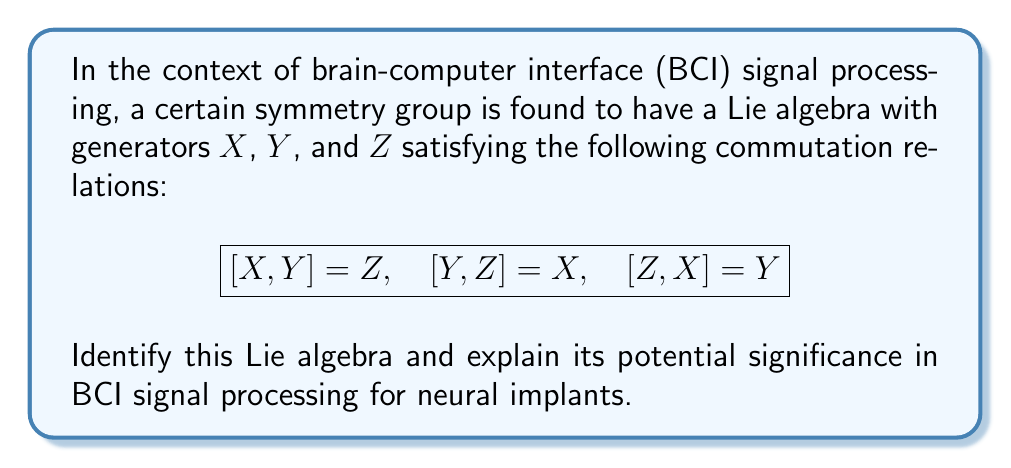Can you answer this question? To identify this Lie algebra, we need to analyze the commutation relations given:

$$[X,Y] = Z, \quad [Y,Z] = X, \quad [Z,X] = Y$$

These relations are characteristic of the special unitary group SU(2), which is isomorphic to the special orthogonal group SO(3). The Lie algebra associated with these groups is denoted as $\mathfrak{su}(2)$ or $\mathfrak{so}(3)$.

The significance of this Lie algebra in BCI signal processing for neural implants can be explained as follows:

1. Rotational symmetry: SO(3) represents 3D rotations, which can be crucial in processing and interpreting spatial data from neural signals. This is particularly relevant when dealing with 3D positioning of electrodes or analyzing spatial patterns of brain activity.

2. Quantum mechanics analogy: SU(2) is closely related to the algebra of spin-1/2 particles in quantum mechanics. This connection could be useful in developing quantum-inspired algorithms for BCI signal processing, potentially leading to more efficient data analysis techniques.

3. Signal transformation: The generators of this Lie algebra can be used to construct rotation matrices or unitary transformations, which can be applied to transform and analyze neural signals in different reference frames or representations.

4. Feature extraction: The symmetry properties of this group can be exploited to design invariant feature extraction methods, which could be valuable in identifying consistent patterns in neural signals across different recording sessions or subjects.

5. Dimensionality reduction: Understanding the symmetries in the signal space can guide dimensionality reduction techniques, potentially leading to more efficient and interpretable representations of neural data.

6. Error correction: The structure of this Lie algebra can be used to develop error correction methods for BCI systems, improving the robustness and reliability of neural implant technology.

From an ethical perspective, understanding the mathematical foundations of BCI signal processing is crucial for ensuring the safety, efficacy, and responsible development of neural implant technology. The use of advanced mathematical tools like Lie algebras in this context raises important questions about data interpretation, potential biases in signal processing algorithms, and the implications of applying abstract mathematical concepts to human cognition and neural function.
Answer: The Lie algebra described by the given commutation relations is $\mathfrak{su}(2)$ or $\mathfrak{so}(3)$, associated with the special unitary group SU(2) or the special orthogonal group SO(3). Its significance in BCI signal processing for neural implants lies in its applications to rotational symmetry, quantum-inspired algorithms, signal transformation, invariant feature extraction, dimensionality reduction, and error correction in neural signal analysis. 